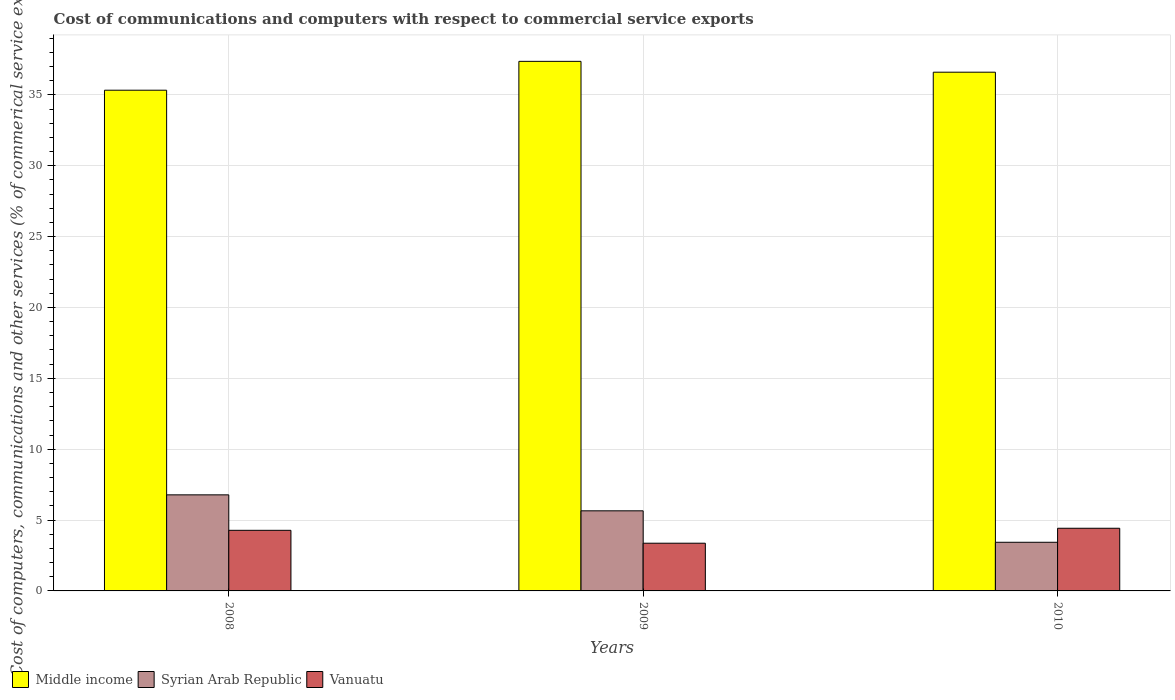What is the label of the 2nd group of bars from the left?
Make the answer very short. 2009. In how many cases, is the number of bars for a given year not equal to the number of legend labels?
Keep it short and to the point. 0. What is the cost of communications and computers in Vanuatu in 2010?
Make the answer very short. 4.42. Across all years, what is the maximum cost of communications and computers in Syrian Arab Republic?
Make the answer very short. 6.78. Across all years, what is the minimum cost of communications and computers in Syrian Arab Republic?
Offer a terse response. 3.43. In which year was the cost of communications and computers in Syrian Arab Republic maximum?
Your response must be concise. 2008. What is the total cost of communications and computers in Middle income in the graph?
Give a very brief answer. 109.29. What is the difference between the cost of communications and computers in Middle income in 2009 and that in 2010?
Your answer should be compact. 0.76. What is the difference between the cost of communications and computers in Syrian Arab Republic in 2008 and the cost of communications and computers in Middle income in 2010?
Make the answer very short. -29.82. What is the average cost of communications and computers in Vanuatu per year?
Provide a succinct answer. 4.02. In the year 2009, what is the difference between the cost of communications and computers in Vanuatu and cost of communications and computers in Middle income?
Your response must be concise. -34. In how many years, is the cost of communications and computers in Syrian Arab Republic greater than 19 %?
Your answer should be very brief. 0. What is the ratio of the cost of communications and computers in Vanuatu in 2008 to that in 2009?
Keep it short and to the point. 1.27. Is the difference between the cost of communications and computers in Vanuatu in 2008 and 2010 greater than the difference between the cost of communications and computers in Middle income in 2008 and 2010?
Your answer should be very brief. Yes. What is the difference between the highest and the second highest cost of communications and computers in Vanuatu?
Your response must be concise. 0.15. What is the difference between the highest and the lowest cost of communications and computers in Syrian Arab Republic?
Provide a succinct answer. 3.35. Is the sum of the cost of communications and computers in Vanuatu in 2009 and 2010 greater than the maximum cost of communications and computers in Syrian Arab Republic across all years?
Offer a terse response. Yes. What does the 1st bar from the left in 2008 represents?
Your answer should be very brief. Middle income. Are all the bars in the graph horizontal?
Your answer should be compact. No. How many years are there in the graph?
Make the answer very short. 3. Are the values on the major ticks of Y-axis written in scientific E-notation?
Make the answer very short. No. Does the graph contain grids?
Provide a short and direct response. Yes. Where does the legend appear in the graph?
Provide a short and direct response. Bottom left. What is the title of the graph?
Keep it short and to the point. Cost of communications and computers with respect to commercial service exports. What is the label or title of the Y-axis?
Provide a succinct answer. Cost of computers, communications and other services (% of commerical service exports). What is the Cost of computers, communications and other services (% of commerical service exports) of Middle income in 2008?
Provide a short and direct response. 35.33. What is the Cost of computers, communications and other services (% of commerical service exports) of Syrian Arab Republic in 2008?
Keep it short and to the point. 6.78. What is the Cost of computers, communications and other services (% of commerical service exports) of Vanuatu in 2008?
Provide a succinct answer. 4.28. What is the Cost of computers, communications and other services (% of commerical service exports) in Middle income in 2009?
Offer a very short reply. 37.36. What is the Cost of computers, communications and other services (% of commerical service exports) in Syrian Arab Republic in 2009?
Your response must be concise. 5.65. What is the Cost of computers, communications and other services (% of commerical service exports) in Vanuatu in 2009?
Make the answer very short. 3.37. What is the Cost of computers, communications and other services (% of commerical service exports) of Middle income in 2010?
Ensure brevity in your answer.  36.6. What is the Cost of computers, communications and other services (% of commerical service exports) of Syrian Arab Republic in 2010?
Provide a short and direct response. 3.43. What is the Cost of computers, communications and other services (% of commerical service exports) in Vanuatu in 2010?
Give a very brief answer. 4.42. Across all years, what is the maximum Cost of computers, communications and other services (% of commerical service exports) of Middle income?
Provide a short and direct response. 37.36. Across all years, what is the maximum Cost of computers, communications and other services (% of commerical service exports) in Syrian Arab Republic?
Provide a succinct answer. 6.78. Across all years, what is the maximum Cost of computers, communications and other services (% of commerical service exports) of Vanuatu?
Offer a very short reply. 4.42. Across all years, what is the minimum Cost of computers, communications and other services (% of commerical service exports) in Middle income?
Offer a terse response. 35.33. Across all years, what is the minimum Cost of computers, communications and other services (% of commerical service exports) in Syrian Arab Republic?
Offer a very short reply. 3.43. Across all years, what is the minimum Cost of computers, communications and other services (% of commerical service exports) of Vanuatu?
Offer a terse response. 3.37. What is the total Cost of computers, communications and other services (% of commerical service exports) of Middle income in the graph?
Keep it short and to the point. 109.29. What is the total Cost of computers, communications and other services (% of commerical service exports) of Syrian Arab Republic in the graph?
Provide a succinct answer. 15.86. What is the total Cost of computers, communications and other services (% of commerical service exports) of Vanuatu in the graph?
Offer a terse response. 12.06. What is the difference between the Cost of computers, communications and other services (% of commerical service exports) in Middle income in 2008 and that in 2009?
Offer a terse response. -2.04. What is the difference between the Cost of computers, communications and other services (% of commerical service exports) in Syrian Arab Republic in 2008 and that in 2009?
Ensure brevity in your answer.  1.13. What is the difference between the Cost of computers, communications and other services (% of commerical service exports) of Vanuatu in 2008 and that in 2009?
Your answer should be very brief. 0.91. What is the difference between the Cost of computers, communications and other services (% of commerical service exports) of Middle income in 2008 and that in 2010?
Ensure brevity in your answer.  -1.27. What is the difference between the Cost of computers, communications and other services (% of commerical service exports) of Syrian Arab Republic in 2008 and that in 2010?
Provide a succinct answer. 3.35. What is the difference between the Cost of computers, communications and other services (% of commerical service exports) in Vanuatu in 2008 and that in 2010?
Your answer should be very brief. -0.15. What is the difference between the Cost of computers, communications and other services (% of commerical service exports) in Middle income in 2009 and that in 2010?
Provide a succinct answer. 0.76. What is the difference between the Cost of computers, communications and other services (% of commerical service exports) of Syrian Arab Republic in 2009 and that in 2010?
Your response must be concise. 2.22. What is the difference between the Cost of computers, communications and other services (% of commerical service exports) of Vanuatu in 2009 and that in 2010?
Your answer should be compact. -1.05. What is the difference between the Cost of computers, communications and other services (% of commerical service exports) in Middle income in 2008 and the Cost of computers, communications and other services (% of commerical service exports) in Syrian Arab Republic in 2009?
Keep it short and to the point. 29.68. What is the difference between the Cost of computers, communications and other services (% of commerical service exports) of Middle income in 2008 and the Cost of computers, communications and other services (% of commerical service exports) of Vanuatu in 2009?
Your response must be concise. 31.96. What is the difference between the Cost of computers, communications and other services (% of commerical service exports) in Syrian Arab Republic in 2008 and the Cost of computers, communications and other services (% of commerical service exports) in Vanuatu in 2009?
Provide a succinct answer. 3.41. What is the difference between the Cost of computers, communications and other services (% of commerical service exports) in Middle income in 2008 and the Cost of computers, communications and other services (% of commerical service exports) in Syrian Arab Republic in 2010?
Your answer should be very brief. 31.89. What is the difference between the Cost of computers, communications and other services (% of commerical service exports) in Middle income in 2008 and the Cost of computers, communications and other services (% of commerical service exports) in Vanuatu in 2010?
Keep it short and to the point. 30.91. What is the difference between the Cost of computers, communications and other services (% of commerical service exports) in Syrian Arab Republic in 2008 and the Cost of computers, communications and other services (% of commerical service exports) in Vanuatu in 2010?
Provide a short and direct response. 2.36. What is the difference between the Cost of computers, communications and other services (% of commerical service exports) of Middle income in 2009 and the Cost of computers, communications and other services (% of commerical service exports) of Syrian Arab Republic in 2010?
Your answer should be compact. 33.93. What is the difference between the Cost of computers, communications and other services (% of commerical service exports) of Middle income in 2009 and the Cost of computers, communications and other services (% of commerical service exports) of Vanuatu in 2010?
Provide a short and direct response. 32.94. What is the difference between the Cost of computers, communications and other services (% of commerical service exports) in Syrian Arab Republic in 2009 and the Cost of computers, communications and other services (% of commerical service exports) in Vanuatu in 2010?
Provide a short and direct response. 1.23. What is the average Cost of computers, communications and other services (% of commerical service exports) of Middle income per year?
Provide a succinct answer. 36.43. What is the average Cost of computers, communications and other services (% of commerical service exports) of Syrian Arab Republic per year?
Offer a terse response. 5.29. What is the average Cost of computers, communications and other services (% of commerical service exports) in Vanuatu per year?
Keep it short and to the point. 4.02. In the year 2008, what is the difference between the Cost of computers, communications and other services (% of commerical service exports) of Middle income and Cost of computers, communications and other services (% of commerical service exports) of Syrian Arab Republic?
Offer a terse response. 28.55. In the year 2008, what is the difference between the Cost of computers, communications and other services (% of commerical service exports) in Middle income and Cost of computers, communications and other services (% of commerical service exports) in Vanuatu?
Keep it short and to the point. 31.05. In the year 2008, what is the difference between the Cost of computers, communications and other services (% of commerical service exports) in Syrian Arab Republic and Cost of computers, communications and other services (% of commerical service exports) in Vanuatu?
Give a very brief answer. 2.5. In the year 2009, what is the difference between the Cost of computers, communications and other services (% of commerical service exports) in Middle income and Cost of computers, communications and other services (% of commerical service exports) in Syrian Arab Republic?
Your answer should be compact. 31.71. In the year 2009, what is the difference between the Cost of computers, communications and other services (% of commerical service exports) in Middle income and Cost of computers, communications and other services (% of commerical service exports) in Vanuatu?
Your response must be concise. 34. In the year 2009, what is the difference between the Cost of computers, communications and other services (% of commerical service exports) in Syrian Arab Republic and Cost of computers, communications and other services (% of commerical service exports) in Vanuatu?
Provide a short and direct response. 2.29. In the year 2010, what is the difference between the Cost of computers, communications and other services (% of commerical service exports) in Middle income and Cost of computers, communications and other services (% of commerical service exports) in Syrian Arab Republic?
Provide a succinct answer. 33.17. In the year 2010, what is the difference between the Cost of computers, communications and other services (% of commerical service exports) in Middle income and Cost of computers, communications and other services (% of commerical service exports) in Vanuatu?
Keep it short and to the point. 32.18. In the year 2010, what is the difference between the Cost of computers, communications and other services (% of commerical service exports) in Syrian Arab Republic and Cost of computers, communications and other services (% of commerical service exports) in Vanuatu?
Give a very brief answer. -0.99. What is the ratio of the Cost of computers, communications and other services (% of commerical service exports) in Middle income in 2008 to that in 2009?
Your answer should be very brief. 0.95. What is the ratio of the Cost of computers, communications and other services (% of commerical service exports) in Syrian Arab Republic in 2008 to that in 2009?
Your answer should be compact. 1.2. What is the ratio of the Cost of computers, communications and other services (% of commerical service exports) in Vanuatu in 2008 to that in 2009?
Give a very brief answer. 1.27. What is the ratio of the Cost of computers, communications and other services (% of commerical service exports) of Middle income in 2008 to that in 2010?
Give a very brief answer. 0.97. What is the ratio of the Cost of computers, communications and other services (% of commerical service exports) in Syrian Arab Republic in 2008 to that in 2010?
Offer a very short reply. 1.98. What is the ratio of the Cost of computers, communications and other services (% of commerical service exports) of Middle income in 2009 to that in 2010?
Ensure brevity in your answer.  1.02. What is the ratio of the Cost of computers, communications and other services (% of commerical service exports) of Syrian Arab Republic in 2009 to that in 2010?
Your response must be concise. 1.65. What is the ratio of the Cost of computers, communications and other services (% of commerical service exports) in Vanuatu in 2009 to that in 2010?
Your response must be concise. 0.76. What is the difference between the highest and the second highest Cost of computers, communications and other services (% of commerical service exports) in Middle income?
Provide a short and direct response. 0.76. What is the difference between the highest and the second highest Cost of computers, communications and other services (% of commerical service exports) of Syrian Arab Republic?
Offer a terse response. 1.13. What is the difference between the highest and the second highest Cost of computers, communications and other services (% of commerical service exports) in Vanuatu?
Provide a succinct answer. 0.15. What is the difference between the highest and the lowest Cost of computers, communications and other services (% of commerical service exports) in Middle income?
Provide a short and direct response. 2.04. What is the difference between the highest and the lowest Cost of computers, communications and other services (% of commerical service exports) of Syrian Arab Republic?
Give a very brief answer. 3.35. What is the difference between the highest and the lowest Cost of computers, communications and other services (% of commerical service exports) in Vanuatu?
Offer a very short reply. 1.05. 